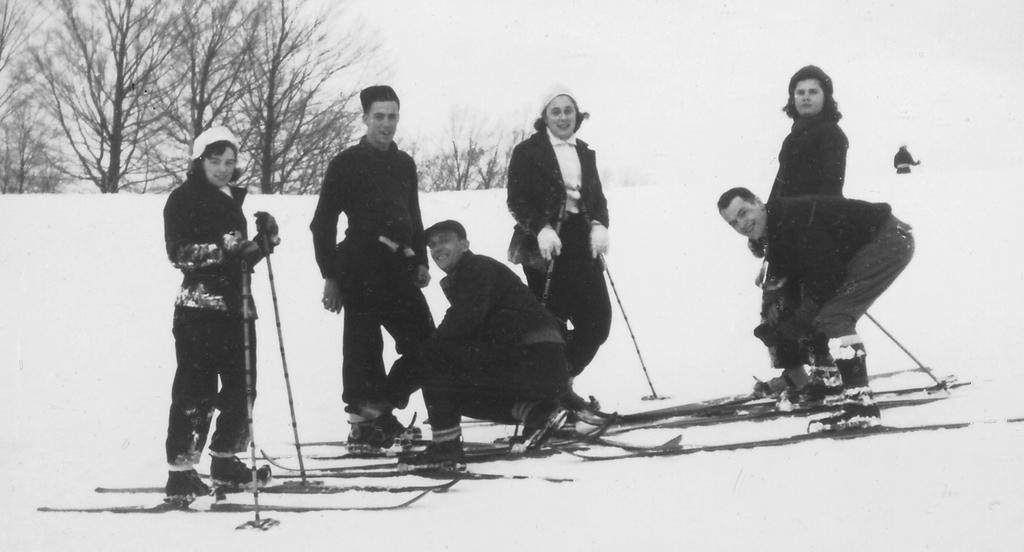How many people are in the image? There are six people in the image. What are some of the people holding? Some of the people are holding sticks. What can be seen at the top of the image? There are trees visible at the top of the image. Where is a person located in the image? There is a person visible on the right side of the image. What type of brush is the person on the right side of the image using? There is no brush present in the image; the person is not using any brush. Who is the father of the person on the right side of the image? There is no information about the person's family in the image, so it is not possible to determine their father. 